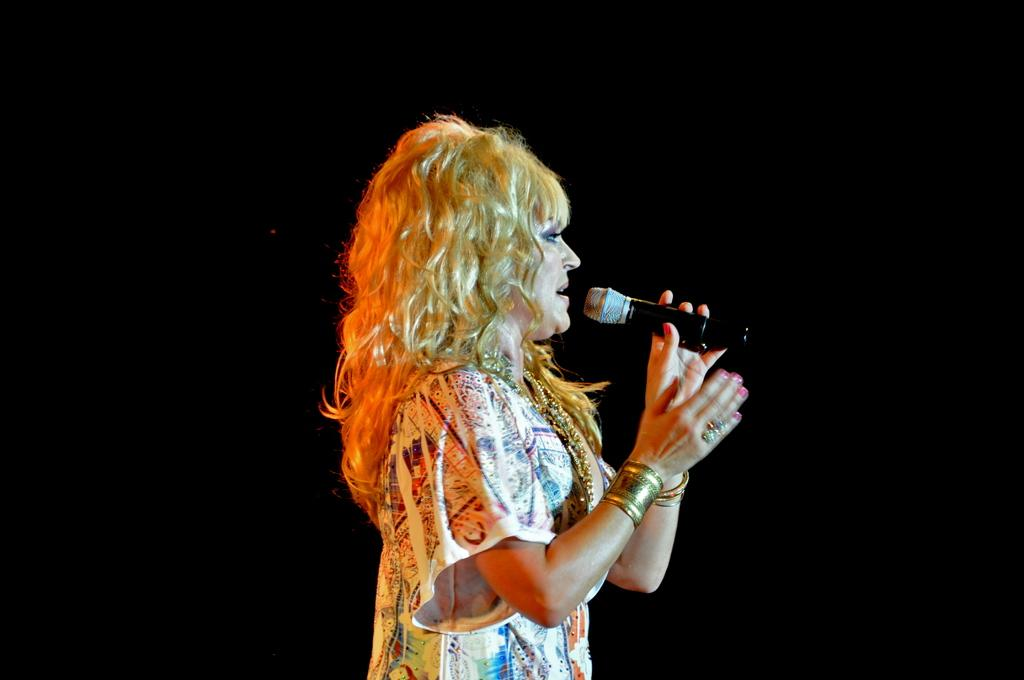Who is the main subject in the image? There is a woman in the image. What is the woman holding in the image? The woman is holding a microphone. What is the woman doing in the image? The woman is singing. What type of secretary is the woman in the image? There is no indication in the image that the woman is a secretary; she is holding a microphone and singing. 